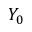Convert formula to latex. <formula><loc_0><loc_0><loc_500><loc_500>Y _ { 0 }</formula> 